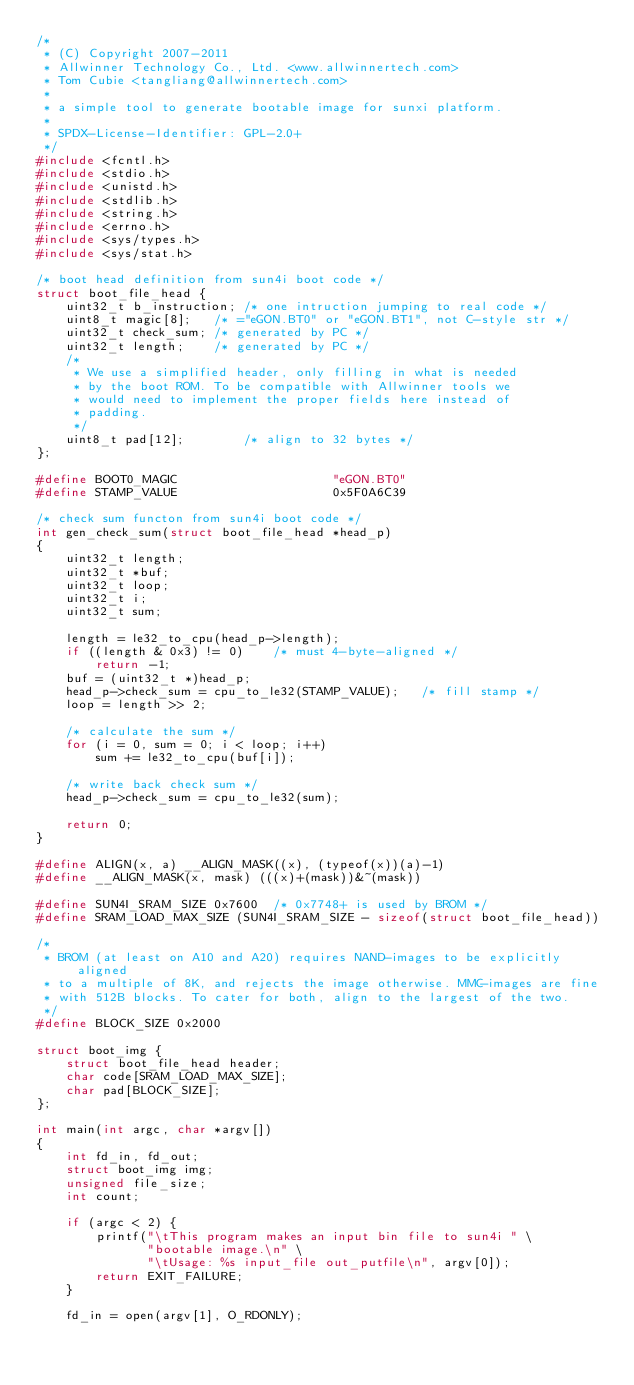Convert code to text. <code><loc_0><loc_0><loc_500><loc_500><_C_>/*
 * (C) Copyright 2007-2011
 * Allwinner Technology Co., Ltd. <www.allwinnertech.com>
 * Tom Cubie <tangliang@allwinnertech.com>
 *
 * a simple tool to generate bootable image for sunxi platform.
 *
 * SPDX-License-Identifier:	GPL-2.0+
 */
#include <fcntl.h>
#include <stdio.h>
#include <unistd.h>
#include <stdlib.h>
#include <string.h>
#include <errno.h>
#include <sys/types.h>
#include <sys/stat.h>

/* boot head definition from sun4i boot code */
struct boot_file_head {
	uint32_t b_instruction;	/* one intruction jumping to real code */
	uint8_t magic[8];	/* ="eGON.BT0" or "eGON.BT1", not C-style str */
	uint32_t check_sum;	/* generated by PC */
	uint32_t length;	/* generated by PC */
	/*
	 * We use a simplified header, only filling in what is needed
	 * by the boot ROM. To be compatible with Allwinner tools we
	 * would need to implement the proper fields here instead of
	 * padding.
	 */
	uint8_t pad[12];		/* align to 32 bytes */
};

#define BOOT0_MAGIC                     "eGON.BT0"
#define STAMP_VALUE                     0x5F0A6C39

/* check sum functon from sun4i boot code */
int gen_check_sum(struct boot_file_head *head_p)
{
	uint32_t length;
	uint32_t *buf;
	uint32_t loop;
	uint32_t i;
	uint32_t sum;

	length = le32_to_cpu(head_p->length);
	if ((length & 0x3) != 0)	/* must 4-byte-aligned */
		return -1;
	buf = (uint32_t *)head_p;
	head_p->check_sum = cpu_to_le32(STAMP_VALUE);	/* fill stamp */
	loop = length >> 2;

	/* calculate the sum */
	for (i = 0, sum = 0; i < loop; i++)
		sum += le32_to_cpu(buf[i]);

	/* write back check sum */
	head_p->check_sum = cpu_to_le32(sum);

	return 0;
}

#define ALIGN(x, a) __ALIGN_MASK((x), (typeof(x))(a)-1)
#define __ALIGN_MASK(x, mask) (((x)+(mask))&~(mask))

#define SUN4I_SRAM_SIZE 0x7600	/* 0x7748+ is used by BROM */
#define SRAM_LOAD_MAX_SIZE (SUN4I_SRAM_SIZE - sizeof(struct boot_file_head))

/*
 * BROM (at least on A10 and A20) requires NAND-images to be explicitly aligned
 * to a multiple of 8K, and rejects the image otherwise. MMC-images are fine
 * with 512B blocks. To cater for both, align to the largest of the two.
 */
#define BLOCK_SIZE 0x2000

struct boot_img {
	struct boot_file_head header;
	char code[SRAM_LOAD_MAX_SIZE];
	char pad[BLOCK_SIZE];
};

int main(int argc, char *argv[])
{
	int fd_in, fd_out;
	struct boot_img img;
	unsigned file_size;
	int count;

	if (argc < 2) {
		printf("\tThis program makes an input bin file to sun4i " \
		       "bootable image.\n" \
		       "\tUsage: %s input_file out_putfile\n", argv[0]);
		return EXIT_FAILURE;
	}

	fd_in = open(argv[1], O_RDONLY);</code> 